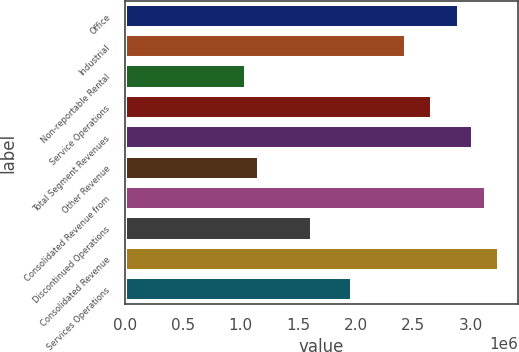Convert chart. <chart><loc_0><loc_0><loc_500><loc_500><bar_chart><fcel>Office<fcel>Industrial<fcel>Non-reportable Rental<fcel>Service Operations<fcel>Total Segment Revenues<fcel>Other Revenue<fcel>Consolidated Revenue from<fcel>Discontinued Operations<fcel>Consolidated Revenue<fcel>Services Operations<nl><fcel>2.89984e+06<fcel>2.43631e+06<fcel>1.04572e+06<fcel>2.66808e+06<fcel>3.01572e+06<fcel>1.1616e+06<fcel>3.13161e+06<fcel>1.62513e+06<fcel>3.24749e+06<fcel>1.97278e+06<nl></chart> 